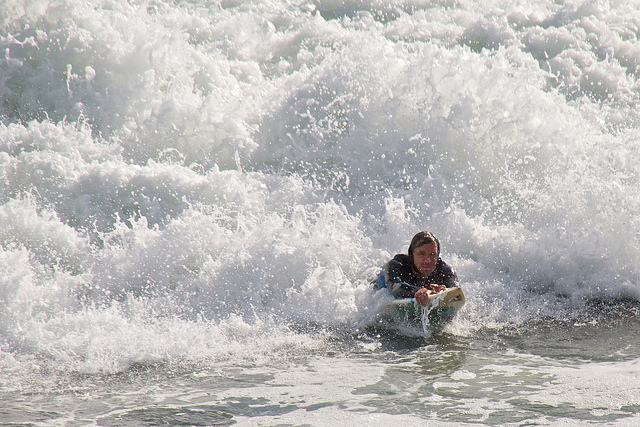What can you say about the weather conditions for surfing in this image? The image suggests good surfing conditions with substantial wave action. The surfer is well-suited with a wetsuit, indicating cooler water temperatures or a desire for protection. 